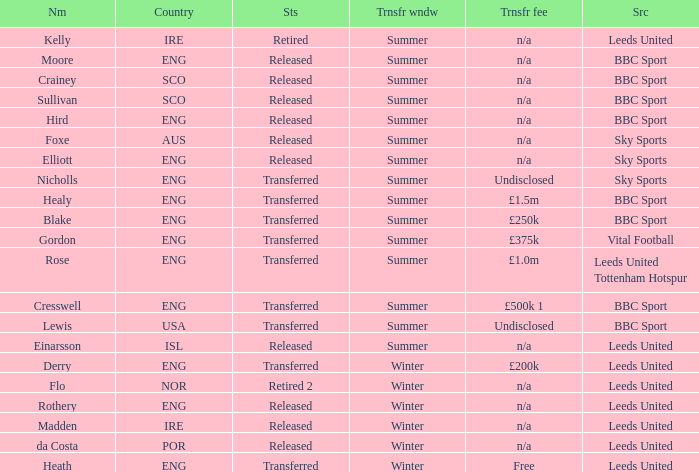What is the person's name that is from the country of SCO? Crainey, Sullivan. 